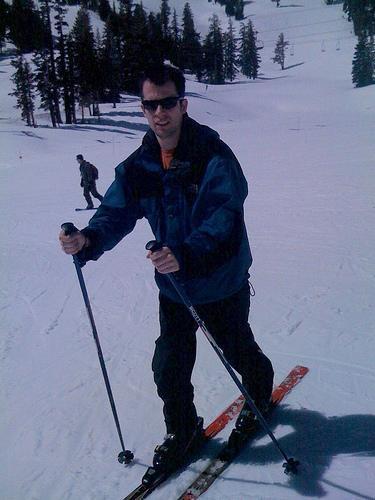How many people are in this photo?
Give a very brief answer. 2. 